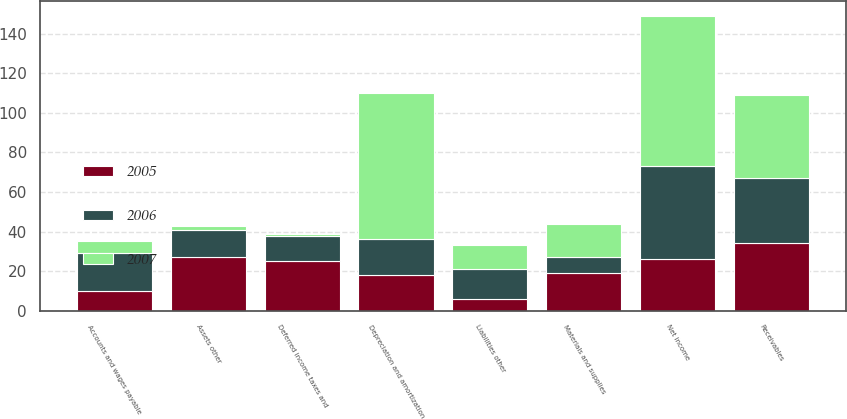Convert chart. <chart><loc_0><loc_0><loc_500><loc_500><stacked_bar_chart><ecel><fcel>Net income<fcel>Depreciation and amortization<fcel>Deferred income taxes and<fcel>Receivables<fcel>Materials and supplies<fcel>Accounts and wages payable<fcel>Assets other<fcel>Liabilities other<nl><fcel>2007<fcel>76<fcel>74<fcel>1<fcel>42<fcel>17<fcel>6<fcel>2<fcel>12<nl><fcel>2006<fcel>47<fcel>18<fcel>13<fcel>33<fcel>8<fcel>19<fcel>14<fcel>15<nl><fcel>2005<fcel>26<fcel>18<fcel>25<fcel>34<fcel>19<fcel>10<fcel>27<fcel>6<nl></chart> 